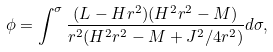Convert formula to latex. <formula><loc_0><loc_0><loc_500><loc_500>\phi = \int ^ { \sigma } \frac { ( L - H r ^ { 2 } ) ( H ^ { 2 } r ^ { 2 } - M ) } { r ^ { 2 } ( H ^ { 2 } r ^ { 2 } - M + J ^ { 2 } / 4 r ^ { 2 } ) } d \sigma ,</formula> 